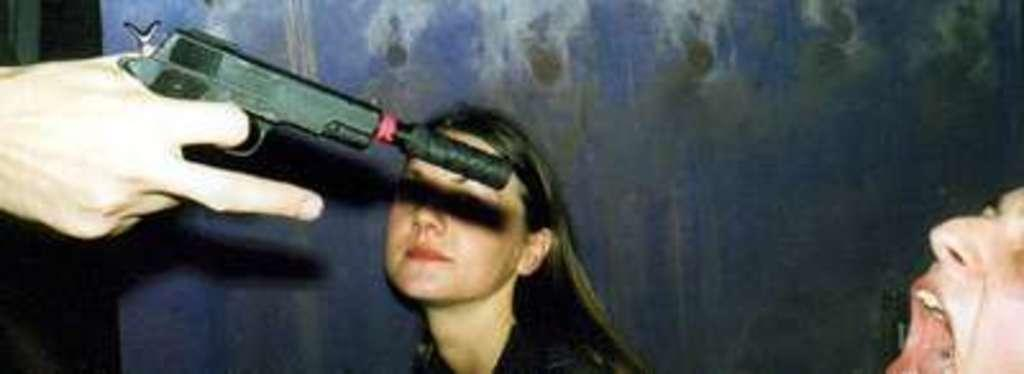How many people are present in the image? There is a man and a woman in the image. What is the gender of the person holding the gun? The person holding the gun is not specified by gender in the image. What color is the background of the image? The background of the image is blue in color. What type of engine can be seen in the image? There is no engine present in the image. What flavor of pie is being served on the table in the image? There is no pie present in the image. 